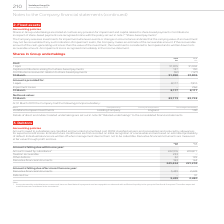From Vodafone Group Plc's financial document, Which financial years' information is shown in the table? The document shows two values: 2018 and 2019. From the document: "2019 €m 2018 €m Cost: 1 April 91,905 91,902 Capital contributions arising from share-based payments 137 2019 €m 2018 €m Cost: 1 April 91,905 91,902 Ca..." Also, What is the net book value as of 31 March in 2019? According to the financial document, 83,773 (in millions). The relevant text states: "Net book value: 31 March 83,773 83,728..." Also, Which financial items does the cost as at 31 March 2019 comprise of? The document contains multiple relevant values: 1 April, Capital contributions arising from share-based payments, Contributions received in relation to share-based payments. From the document: "2019 €m 2018 €m Cost: 1 April 91,905 91,902 Capital contributions arising from share-based payments 137 130 Contributions received in relation to shar..." Also, can you calculate: What is the 2019 average net book value as at 31 March ? To answer this question, I need to perform calculations using the financial data. The calculation is: (83,773+83,728)/2, which equals 83750.5 (in millions). This is based on the information: "Net book value: 31 March 83,773 83,728 Net book value: 31 March 83,773 83,728..." The key data points involved are: 83,728, 83,773. Also, can you calculate: What is the 2019 average total cost of shares in Group undertakings as at 31 March? To answer this question, I need to perform calculations using the financial data. The calculation is: (91,950+91,905)/2, which equals 91927.5 (in millions). This is based on the information: "2019 €m 2018 €m Cost: 1 April 91,905 91,902 Capital contributions arising from share-based payments 137 130 Contributions received in re ation to share-based payments (92) (127) 31 March 91,950 91,905..." The key data points involved are: 91,905, 91,950. Also, can you calculate: What is the difference between 2019 average net book value and 2019 average total costs of shares in Group undertakings as at 31 March? To answer this question, I need to perform calculations using the financial data. The calculation is: [(91,950+91,905)/2] - [(83,773+83,728)/2], which equals 8177 (in millions). This is based on the information: "2019 €m 2018 €m Cost: 1 April 91,905 91,902 Capital contributions arising from share-based payments 137 130 Contributions received in re 2019 €m 2018 €m Cost: 1 April 91,905 91,902 Capital contributio..." The key data points involved are: 2, 83,728, 83,773. 